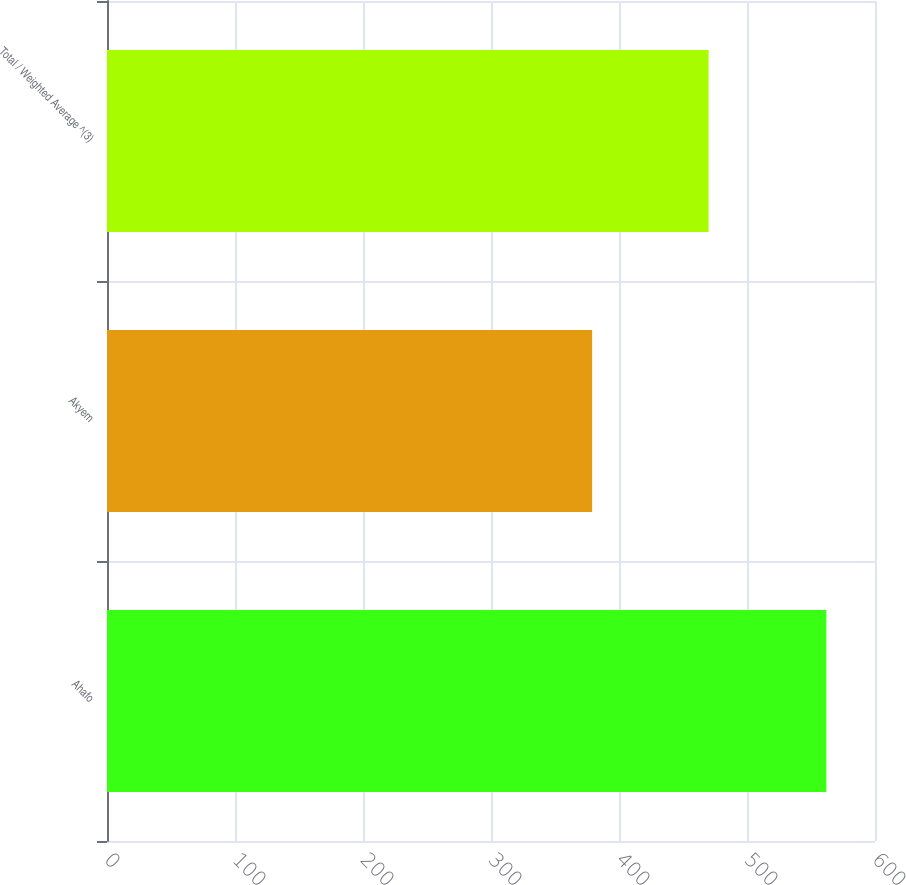<chart> <loc_0><loc_0><loc_500><loc_500><bar_chart><fcel>Ahafo<fcel>Akyem<fcel>Total / Weighted Average ^(3)<nl><fcel>562<fcel>379<fcel>470<nl></chart> 